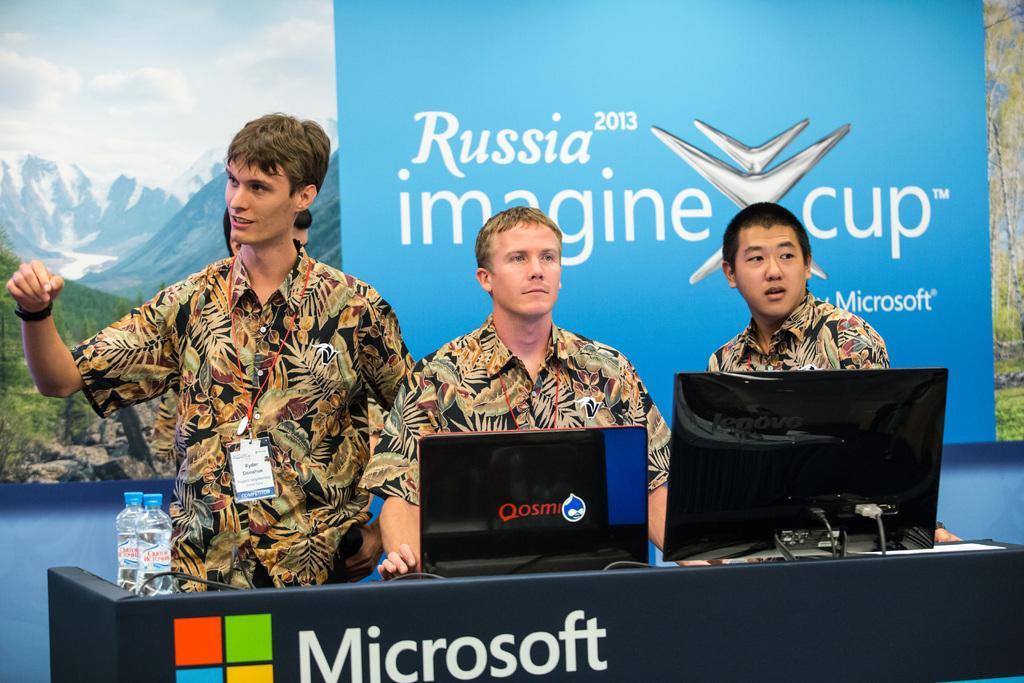Describe this image in one or two sentences. In this image there are three persons standing. They are wearing tags. In front of them there is a stand. On that there are bottles and systems. In the back there is a banner with something written. In the background there is a wallpaper of hills, sky and trees. 